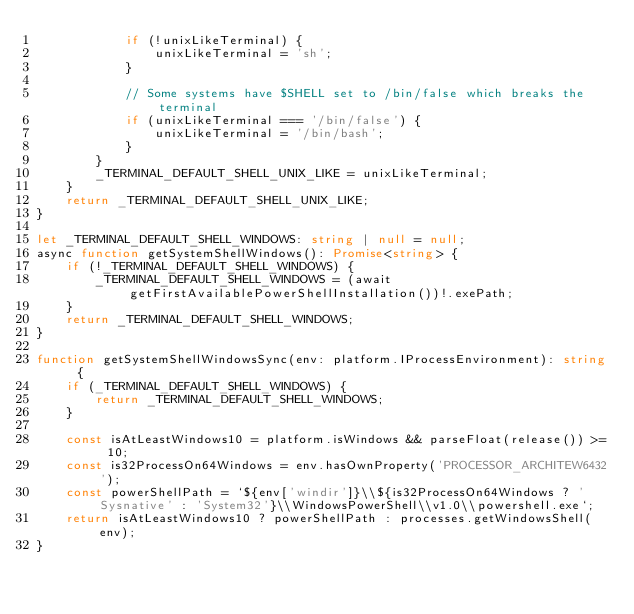Convert code to text. <code><loc_0><loc_0><loc_500><loc_500><_TypeScript_>			if (!unixLikeTerminal) {
				unixLikeTerminal = 'sh';
			}

			// Some systems have $SHELL set to /bin/false which breaks the terminal
			if (unixLikeTerminal === '/bin/false') {
				unixLikeTerminal = '/bin/bash';
			}
		}
		_TERMINAL_DEFAULT_SHELL_UNIX_LIKE = unixLikeTerminal;
	}
	return _TERMINAL_DEFAULT_SHELL_UNIX_LIKE;
}

let _TERMINAL_DEFAULT_SHELL_WINDOWS: string | null = null;
async function getSystemShellWindows(): Promise<string> {
	if (!_TERMINAL_DEFAULT_SHELL_WINDOWS) {
		_TERMINAL_DEFAULT_SHELL_WINDOWS = (await getFirstAvailablePowerShellInstallation())!.exePath;
	}
	return _TERMINAL_DEFAULT_SHELL_WINDOWS;
}

function getSystemShellWindowsSync(env: platform.IProcessEnvironment): string {
	if (_TERMINAL_DEFAULT_SHELL_WINDOWS) {
		return _TERMINAL_DEFAULT_SHELL_WINDOWS;
	}

	const isAtLeastWindows10 = platform.isWindows && parseFloat(release()) >= 10;
	const is32ProcessOn64Windows = env.hasOwnProperty('PROCESSOR_ARCHITEW6432');
	const powerShellPath = `${env['windir']}\\${is32ProcessOn64Windows ? 'Sysnative' : 'System32'}\\WindowsPowerShell\\v1.0\\powershell.exe`;
	return isAtLeastWindows10 ? powerShellPath : processes.getWindowsShell(env);
}
</code> 